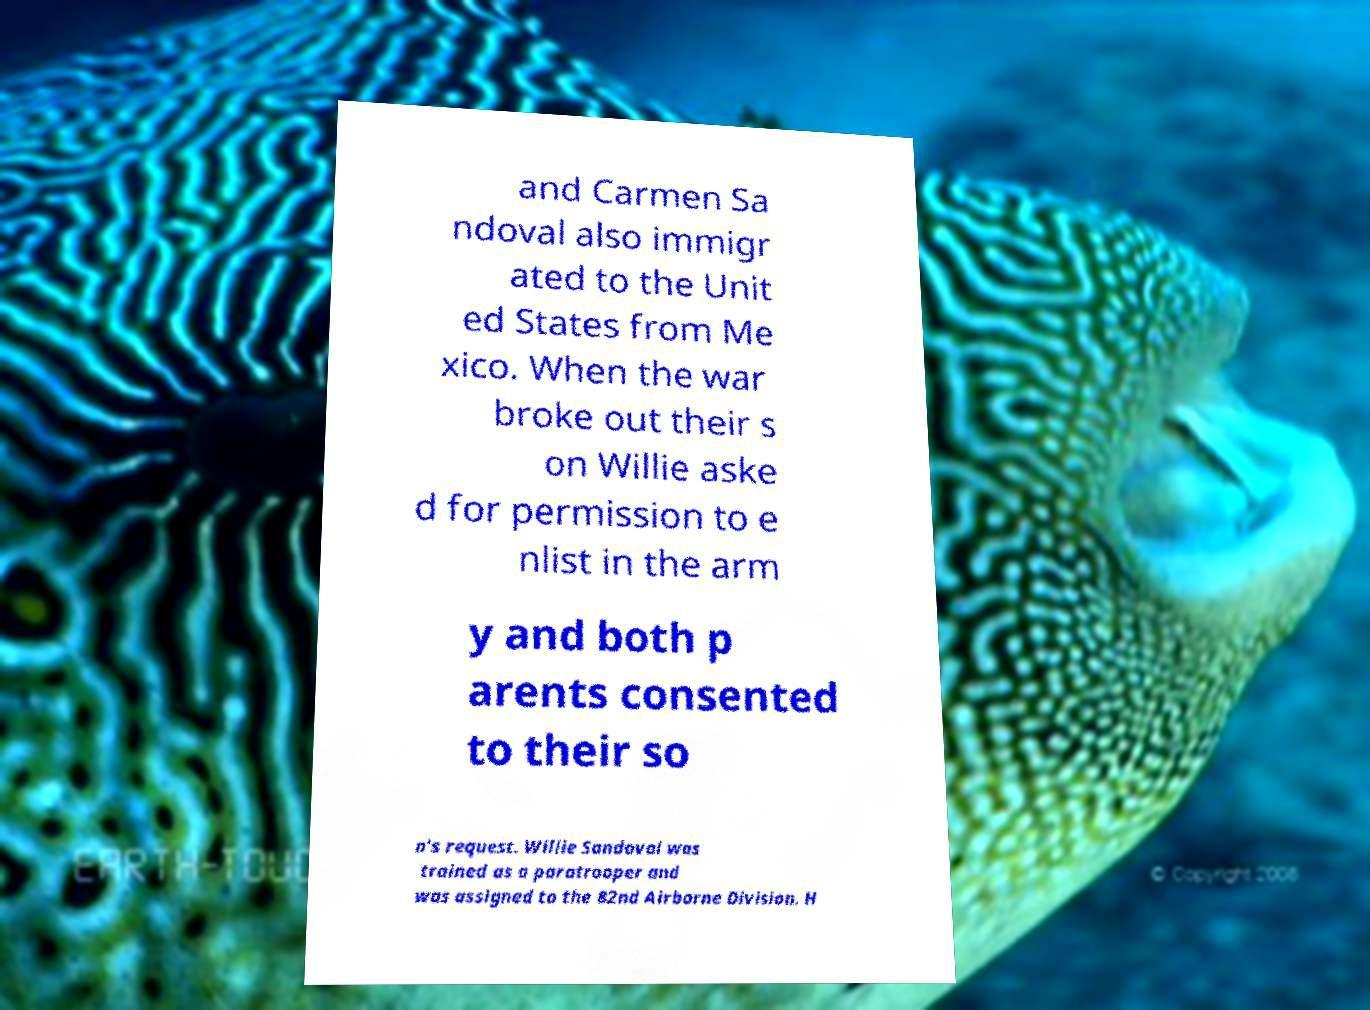For documentation purposes, I need the text within this image transcribed. Could you provide that? and Carmen Sa ndoval also immigr ated to the Unit ed States from Me xico. When the war broke out their s on Willie aske d for permission to e nlist in the arm y and both p arents consented to their so n's request. Willie Sandoval was trained as a paratrooper and was assigned to the 82nd Airborne Division. H 